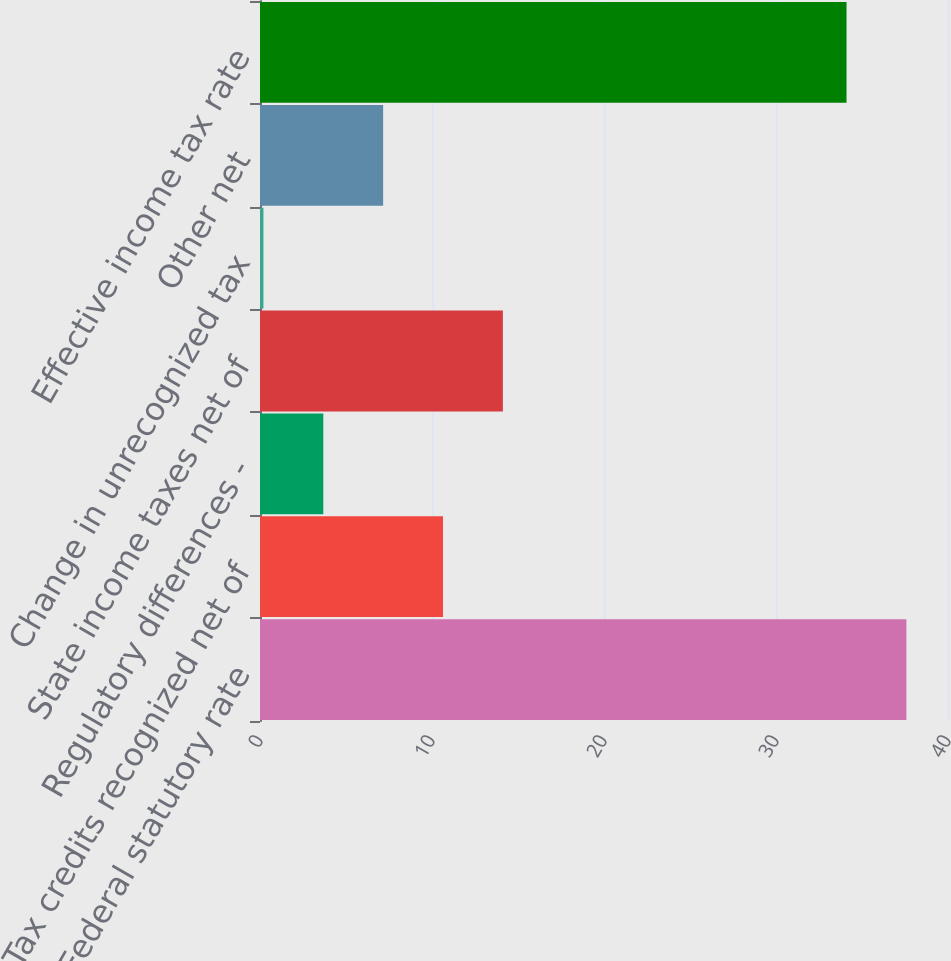<chart> <loc_0><loc_0><loc_500><loc_500><bar_chart><fcel>Federal statutory rate<fcel>Tax credits recognized net of<fcel>Regulatory differences -<fcel>State income taxes net of<fcel>Change in unrecognized tax<fcel>Other net<fcel>Effective income tax rate<nl><fcel>37.58<fcel>10.64<fcel>3.68<fcel>14.12<fcel>0.2<fcel>7.16<fcel>34.1<nl></chart> 